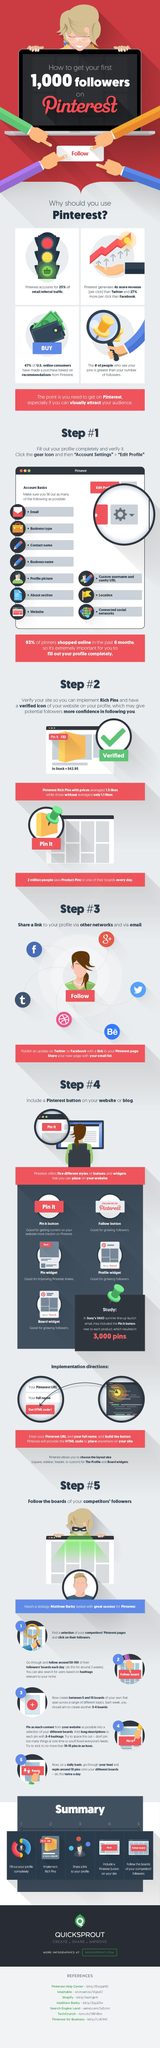Point out several critical features in this image. What type of Pinterest rich pins had more average likes, specifically those with prices, were analyzed to determine their popularity. 